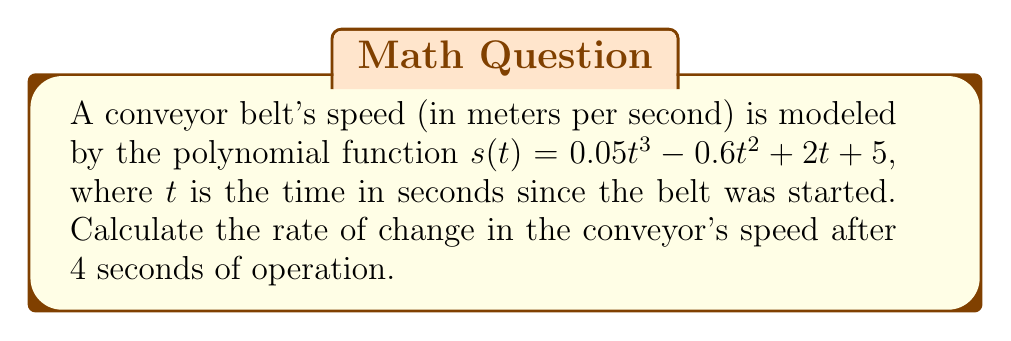Can you answer this question? To find the rate of change in the conveyor's speed, we need to calculate the derivative of the speed function and evaluate it at $t = 4$ seconds.

Step 1: Find the derivative of $s(t)$
$$s'(t) = \frac{d}{dt}(0.05t^3 - 0.6t^2 + 2t + 5)$$
Using the power rule:
$$s'(t) = 0.15t^2 - 1.2t + 2$$

Step 2: Evaluate $s'(t)$ at $t = 4$
$$s'(4) = 0.15(4)^2 - 1.2(4) + 2$$
$$s'(4) = 0.15(16) - 4.8 + 2$$
$$s'(4) = 2.4 - 4.8 + 2$$
$$s'(4) = -0.4$$

The negative value indicates that the speed is decreasing at this point in time.
Answer: $-0.4$ m/s² 